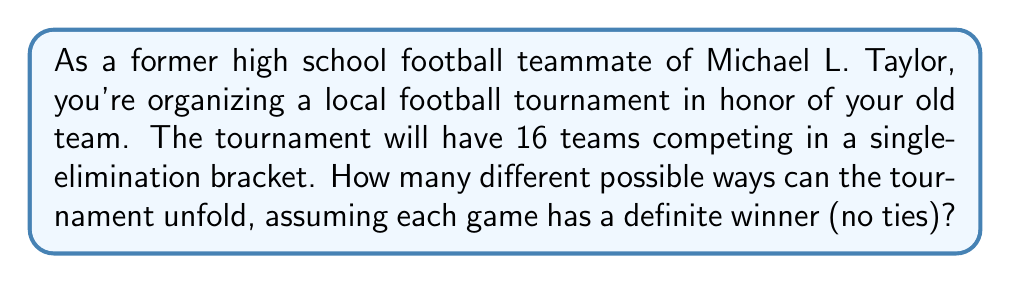Show me your answer to this math problem. Let's approach this step-by-step:

1) In a single-elimination tournament with 16 teams, there will be 15 games total (one game eliminates one team, and we need to eliminate 15 teams to get a winner).

2) For each game, there are 2 possible outcomes (either team can win).

3) The total number of possible tournament outcomes is the product of the number of possible outcomes for each game.

4) Therefore, we can express this mathematically as:

   $$\text{Total outcomes} = 2^{15}$$

5) This is because we're multiplying 2 by itself 15 times (once for each game).

6) To calculate this:

   $$2^{15} = 2 \times 2 \times 2 \times ... \text{ (15 times)} ... \times 2 = 32,768$$

Thus, there are 32,768 different ways the tournament could unfold.

This large number demonstrates why predicting the exact outcome of a tournament is so difficult, even when you know the teams well!
Answer: $32,768$ 